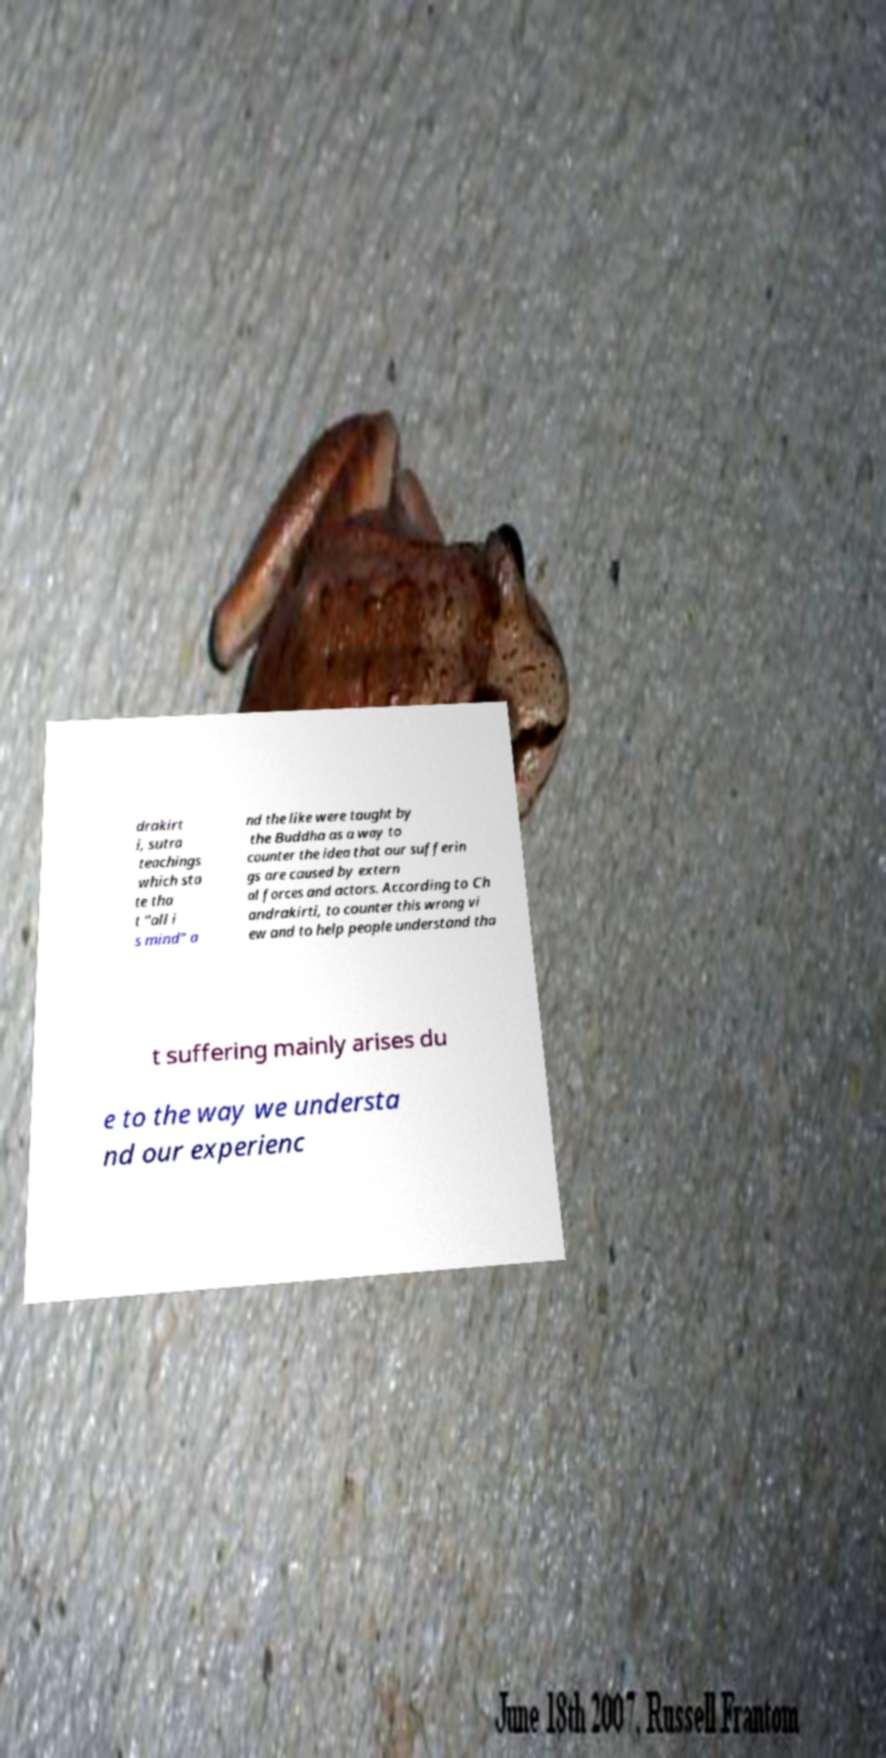Can you read and provide the text displayed in the image?This photo seems to have some interesting text. Can you extract and type it out for me? drakirt i, sutra teachings which sta te tha t "all i s mind" a nd the like were taught by the Buddha as a way to counter the idea that our sufferin gs are caused by extern al forces and actors. According to Ch andrakirti, to counter this wrong vi ew and to help people understand tha t suffering mainly arises du e to the way we understa nd our experienc 